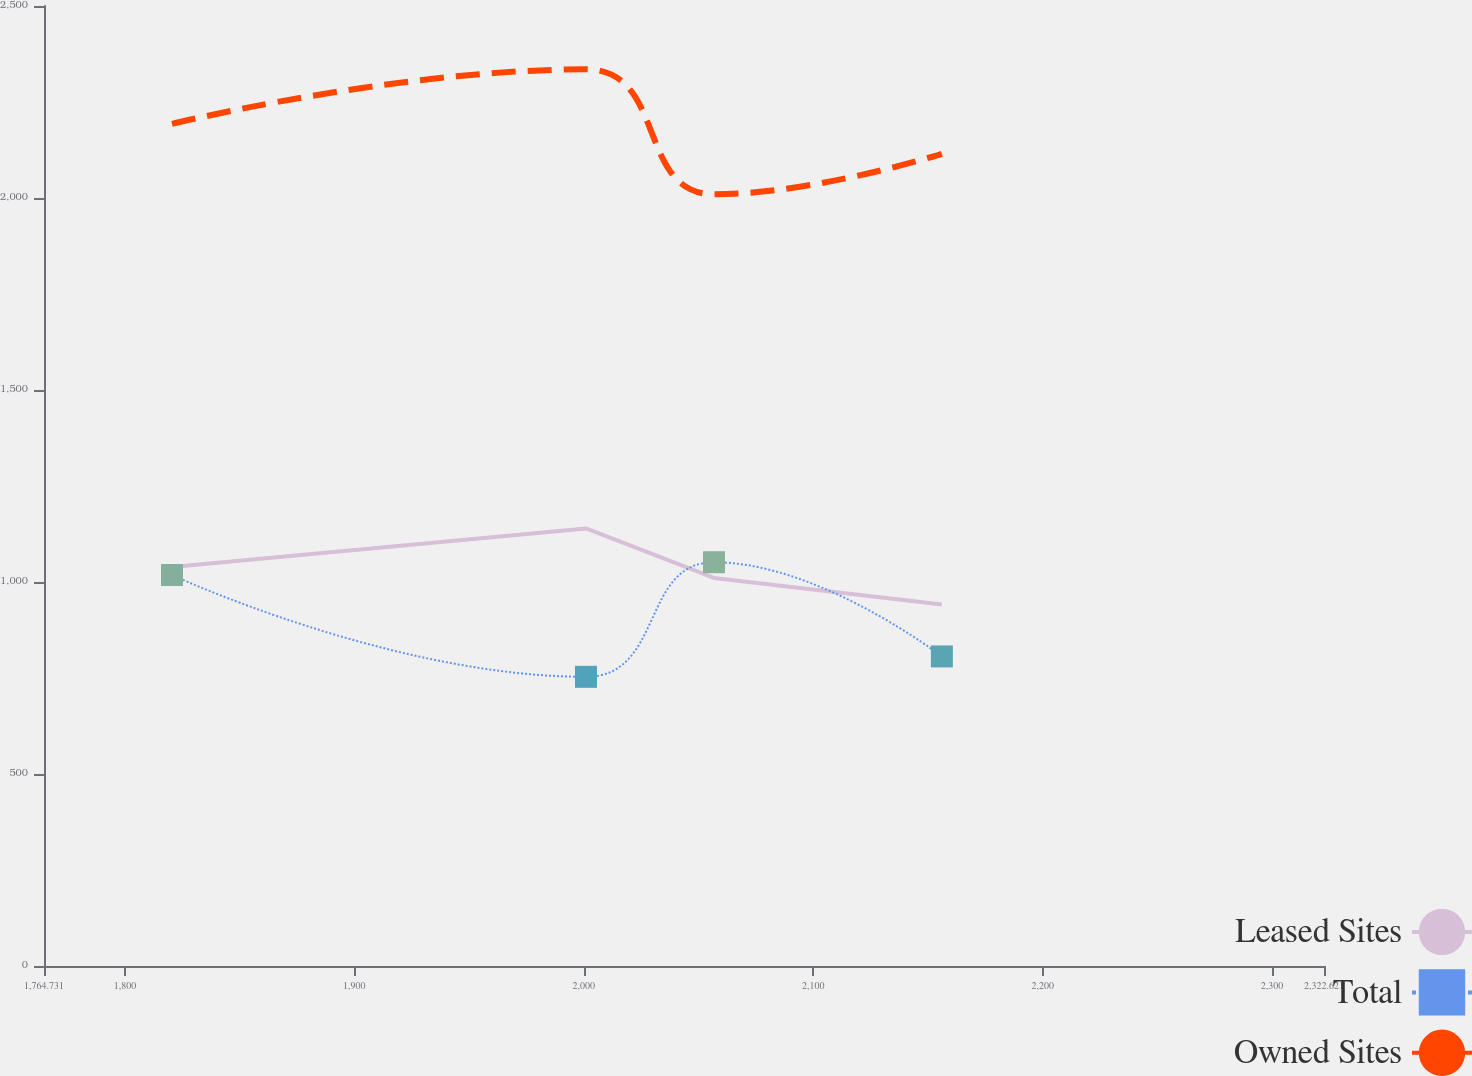Convert chart to OTSL. <chart><loc_0><loc_0><loc_500><loc_500><line_chart><ecel><fcel>Leased Sites<fcel>Total<fcel>Owned Sites<nl><fcel>1820.52<fcel>1038.91<fcel>1018.16<fcel>2193.17<nl><fcel>2000.97<fcel>1139.56<fcel>753.09<fcel>2335.09<nl><fcel>2056.76<fcel>1010.62<fcel>1051.46<fcel>2009.74<nl><fcel>2156.07<fcel>941.13<fcel>806.16<fcel>2115.13<nl><fcel>2378.41<fcel>856.69<fcel>902.85<fcel>1554.73<nl></chart> 